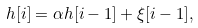<formula> <loc_0><loc_0><loc_500><loc_500>h [ i ] = \alpha h [ i - 1 ] + \xi [ i - 1 ] ,</formula> 